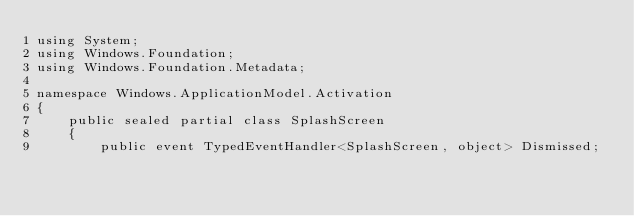<code> <loc_0><loc_0><loc_500><loc_500><_C#_>using System;
using Windows.Foundation;
using Windows.Foundation.Metadata;

namespace Windows.ApplicationModel.Activation
{
	public sealed partial class SplashScreen
	{
		public event TypedEventHandler<SplashScreen, object> Dismissed;
</code> 